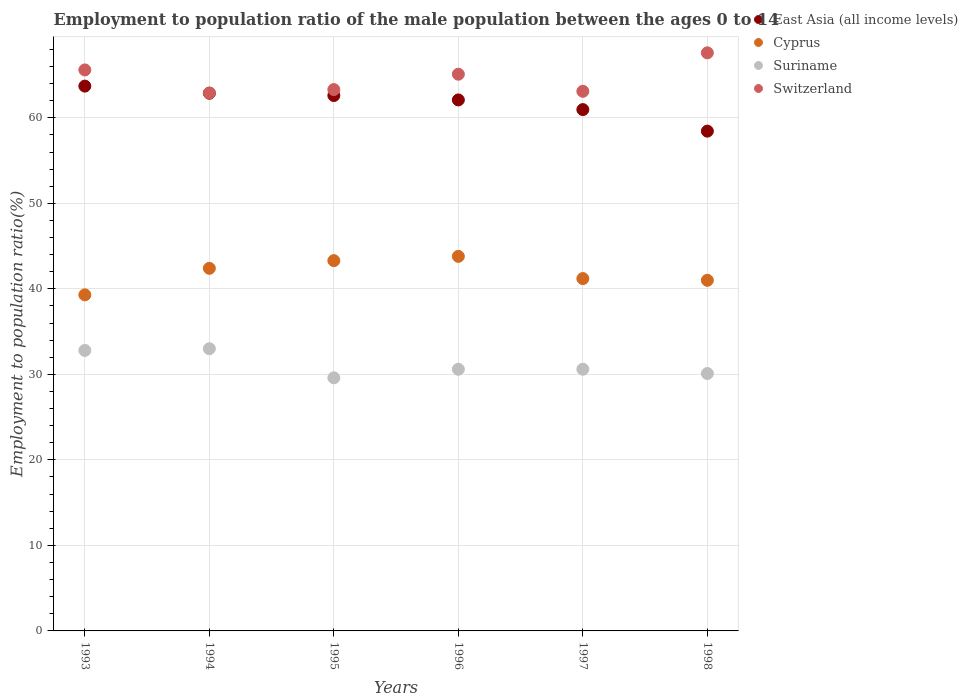How many different coloured dotlines are there?
Keep it short and to the point. 4. What is the employment to population ratio in Switzerland in 1996?
Provide a short and direct response. 65.1. Across all years, what is the maximum employment to population ratio in Suriname?
Make the answer very short. 33. Across all years, what is the minimum employment to population ratio in Suriname?
Make the answer very short. 29.6. In which year was the employment to population ratio in Suriname maximum?
Make the answer very short. 1994. In which year was the employment to population ratio in Suriname minimum?
Offer a very short reply. 1995. What is the total employment to population ratio in East Asia (all income levels) in the graph?
Offer a very short reply. 370.69. What is the difference between the employment to population ratio in Suriname in 1993 and that in 1994?
Ensure brevity in your answer.  -0.2. What is the difference between the employment to population ratio in Suriname in 1998 and the employment to population ratio in East Asia (all income levels) in 1994?
Provide a short and direct response. -32.77. What is the average employment to population ratio in Cyprus per year?
Your response must be concise. 41.83. In the year 1995, what is the difference between the employment to population ratio in Switzerland and employment to population ratio in Suriname?
Your answer should be very brief. 33.7. What is the ratio of the employment to population ratio in Cyprus in 1995 to that in 1998?
Make the answer very short. 1.06. What is the difference between the highest and the second highest employment to population ratio in Cyprus?
Provide a short and direct response. 0.5. What is the difference between the highest and the lowest employment to population ratio in Cyprus?
Offer a very short reply. 4.5. Is the sum of the employment to population ratio in Suriname in 1993 and 1996 greater than the maximum employment to population ratio in East Asia (all income levels) across all years?
Keep it short and to the point. No. Is it the case that in every year, the sum of the employment to population ratio in East Asia (all income levels) and employment to population ratio in Cyprus  is greater than the sum of employment to population ratio in Switzerland and employment to population ratio in Suriname?
Provide a succinct answer. Yes. Does the employment to population ratio in Switzerland monotonically increase over the years?
Offer a terse response. No. How many dotlines are there?
Your answer should be compact. 4. Where does the legend appear in the graph?
Offer a terse response. Top right. How are the legend labels stacked?
Offer a very short reply. Vertical. What is the title of the graph?
Offer a very short reply. Employment to population ratio of the male population between the ages 0 to 14. What is the label or title of the X-axis?
Your answer should be compact. Years. What is the label or title of the Y-axis?
Give a very brief answer. Employment to population ratio(%). What is the Employment to population ratio(%) of East Asia (all income levels) in 1993?
Ensure brevity in your answer.  63.71. What is the Employment to population ratio(%) of Cyprus in 1993?
Offer a very short reply. 39.3. What is the Employment to population ratio(%) of Suriname in 1993?
Offer a very short reply. 32.8. What is the Employment to population ratio(%) of Switzerland in 1993?
Your response must be concise. 65.6. What is the Employment to population ratio(%) of East Asia (all income levels) in 1994?
Offer a very short reply. 62.87. What is the Employment to population ratio(%) in Cyprus in 1994?
Your answer should be very brief. 42.4. What is the Employment to population ratio(%) in Switzerland in 1994?
Offer a terse response. 62.9. What is the Employment to population ratio(%) of East Asia (all income levels) in 1995?
Make the answer very short. 62.61. What is the Employment to population ratio(%) of Cyprus in 1995?
Offer a terse response. 43.3. What is the Employment to population ratio(%) in Suriname in 1995?
Make the answer very short. 29.6. What is the Employment to population ratio(%) of Switzerland in 1995?
Provide a short and direct response. 63.3. What is the Employment to population ratio(%) of East Asia (all income levels) in 1996?
Provide a short and direct response. 62.09. What is the Employment to population ratio(%) in Cyprus in 1996?
Make the answer very short. 43.8. What is the Employment to population ratio(%) in Suriname in 1996?
Provide a short and direct response. 30.6. What is the Employment to population ratio(%) of Switzerland in 1996?
Offer a terse response. 65.1. What is the Employment to population ratio(%) in East Asia (all income levels) in 1997?
Keep it short and to the point. 60.96. What is the Employment to population ratio(%) in Cyprus in 1997?
Offer a very short reply. 41.2. What is the Employment to population ratio(%) in Suriname in 1997?
Offer a very short reply. 30.6. What is the Employment to population ratio(%) in Switzerland in 1997?
Your answer should be compact. 63.1. What is the Employment to population ratio(%) of East Asia (all income levels) in 1998?
Your answer should be very brief. 58.44. What is the Employment to population ratio(%) of Suriname in 1998?
Offer a very short reply. 30.1. What is the Employment to population ratio(%) of Switzerland in 1998?
Your answer should be compact. 67.6. Across all years, what is the maximum Employment to population ratio(%) in East Asia (all income levels)?
Provide a succinct answer. 63.71. Across all years, what is the maximum Employment to population ratio(%) in Cyprus?
Your response must be concise. 43.8. Across all years, what is the maximum Employment to population ratio(%) in Suriname?
Make the answer very short. 33. Across all years, what is the maximum Employment to population ratio(%) of Switzerland?
Provide a short and direct response. 67.6. Across all years, what is the minimum Employment to population ratio(%) of East Asia (all income levels)?
Keep it short and to the point. 58.44. Across all years, what is the minimum Employment to population ratio(%) in Cyprus?
Your answer should be very brief. 39.3. Across all years, what is the minimum Employment to population ratio(%) in Suriname?
Offer a terse response. 29.6. Across all years, what is the minimum Employment to population ratio(%) in Switzerland?
Make the answer very short. 62.9. What is the total Employment to population ratio(%) in East Asia (all income levels) in the graph?
Keep it short and to the point. 370.69. What is the total Employment to population ratio(%) in Cyprus in the graph?
Keep it short and to the point. 251. What is the total Employment to population ratio(%) of Suriname in the graph?
Your answer should be very brief. 186.7. What is the total Employment to population ratio(%) of Switzerland in the graph?
Keep it short and to the point. 387.6. What is the difference between the Employment to population ratio(%) in East Asia (all income levels) in 1993 and that in 1994?
Provide a succinct answer. 0.83. What is the difference between the Employment to population ratio(%) of Cyprus in 1993 and that in 1994?
Make the answer very short. -3.1. What is the difference between the Employment to population ratio(%) in East Asia (all income levels) in 1993 and that in 1995?
Keep it short and to the point. 1.1. What is the difference between the Employment to population ratio(%) of Cyprus in 1993 and that in 1995?
Your response must be concise. -4. What is the difference between the Employment to population ratio(%) of Switzerland in 1993 and that in 1995?
Provide a succinct answer. 2.3. What is the difference between the Employment to population ratio(%) of East Asia (all income levels) in 1993 and that in 1996?
Your answer should be very brief. 1.62. What is the difference between the Employment to population ratio(%) in Cyprus in 1993 and that in 1996?
Offer a very short reply. -4.5. What is the difference between the Employment to population ratio(%) of Switzerland in 1993 and that in 1996?
Your answer should be very brief. 0.5. What is the difference between the Employment to population ratio(%) of East Asia (all income levels) in 1993 and that in 1997?
Make the answer very short. 2.75. What is the difference between the Employment to population ratio(%) in East Asia (all income levels) in 1993 and that in 1998?
Give a very brief answer. 5.26. What is the difference between the Employment to population ratio(%) in Suriname in 1993 and that in 1998?
Offer a very short reply. 2.7. What is the difference between the Employment to population ratio(%) of Switzerland in 1993 and that in 1998?
Keep it short and to the point. -2. What is the difference between the Employment to population ratio(%) of East Asia (all income levels) in 1994 and that in 1995?
Offer a terse response. 0.27. What is the difference between the Employment to population ratio(%) in Cyprus in 1994 and that in 1995?
Keep it short and to the point. -0.9. What is the difference between the Employment to population ratio(%) in Suriname in 1994 and that in 1995?
Your response must be concise. 3.4. What is the difference between the Employment to population ratio(%) in Switzerland in 1994 and that in 1995?
Your response must be concise. -0.4. What is the difference between the Employment to population ratio(%) in East Asia (all income levels) in 1994 and that in 1996?
Ensure brevity in your answer.  0.78. What is the difference between the Employment to population ratio(%) in East Asia (all income levels) in 1994 and that in 1997?
Provide a succinct answer. 1.91. What is the difference between the Employment to population ratio(%) in Cyprus in 1994 and that in 1997?
Ensure brevity in your answer.  1.2. What is the difference between the Employment to population ratio(%) in Suriname in 1994 and that in 1997?
Offer a terse response. 2.4. What is the difference between the Employment to population ratio(%) in East Asia (all income levels) in 1994 and that in 1998?
Ensure brevity in your answer.  4.43. What is the difference between the Employment to population ratio(%) in Cyprus in 1994 and that in 1998?
Your response must be concise. 1.4. What is the difference between the Employment to population ratio(%) of Suriname in 1994 and that in 1998?
Your answer should be very brief. 2.9. What is the difference between the Employment to population ratio(%) of East Asia (all income levels) in 1995 and that in 1996?
Make the answer very short. 0.52. What is the difference between the Employment to population ratio(%) in Suriname in 1995 and that in 1996?
Offer a very short reply. -1. What is the difference between the Employment to population ratio(%) in East Asia (all income levels) in 1995 and that in 1997?
Make the answer very short. 1.65. What is the difference between the Employment to population ratio(%) of East Asia (all income levels) in 1995 and that in 1998?
Ensure brevity in your answer.  4.17. What is the difference between the Employment to population ratio(%) of Cyprus in 1995 and that in 1998?
Your answer should be compact. 2.3. What is the difference between the Employment to population ratio(%) in Suriname in 1995 and that in 1998?
Give a very brief answer. -0.5. What is the difference between the Employment to population ratio(%) in East Asia (all income levels) in 1996 and that in 1997?
Keep it short and to the point. 1.13. What is the difference between the Employment to population ratio(%) of Suriname in 1996 and that in 1997?
Provide a short and direct response. 0. What is the difference between the Employment to population ratio(%) in Switzerland in 1996 and that in 1997?
Offer a very short reply. 2. What is the difference between the Employment to population ratio(%) of East Asia (all income levels) in 1996 and that in 1998?
Offer a very short reply. 3.65. What is the difference between the Employment to population ratio(%) of Cyprus in 1996 and that in 1998?
Provide a succinct answer. 2.8. What is the difference between the Employment to population ratio(%) in East Asia (all income levels) in 1997 and that in 1998?
Provide a succinct answer. 2.52. What is the difference between the Employment to population ratio(%) in Suriname in 1997 and that in 1998?
Keep it short and to the point. 0.5. What is the difference between the Employment to population ratio(%) of East Asia (all income levels) in 1993 and the Employment to population ratio(%) of Cyprus in 1994?
Your response must be concise. 21.31. What is the difference between the Employment to population ratio(%) in East Asia (all income levels) in 1993 and the Employment to population ratio(%) in Suriname in 1994?
Provide a succinct answer. 30.71. What is the difference between the Employment to population ratio(%) of East Asia (all income levels) in 1993 and the Employment to population ratio(%) of Switzerland in 1994?
Make the answer very short. 0.81. What is the difference between the Employment to population ratio(%) of Cyprus in 1993 and the Employment to population ratio(%) of Suriname in 1994?
Make the answer very short. 6.3. What is the difference between the Employment to population ratio(%) in Cyprus in 1993 and the Employment to population ratio(%) in Switzerland in 1994?
Ensure brevity in your answer.  -23.6. What is the difference between the Employment to population ratio(%) of Suriname in 1993 and the Employment to population ratio(%) of Switzerland in 1994?
Keep it short and to the point. -30.1. What is the difference between the Employment to population ratio(%) in East Asia (all income levels) in 1993 and the Employment to population ratio(%) in Cyprus in 1995?
Keep it short and to the point. 20.41. What is the difference between the Employment to population ratio(%) of East Asia (all income levels) in 1993 and the Employment to population ratio(%) of Suriname in 1995?
Offer a very short reply. 34.11. What is the difference between the Employment to population ratio(%) in East Asia (all income levels) in 1993 and the Employment to population ratio(%) in Switzerland in 1995?
Provide a short and direct response. 0.41. What is the difference between the Employment to population ratio(%) of Suriname in 1993 and the Employment to population ratio(%) of Switzerland in 1995?
Offer a very short reply. -30.5. What is the difference between the Employment to population ratio(%) of East Asia (all income levels) in 1993 and the Employment to population ratio(%) of Cyprus in 1996?
Provide a short and direct response. 19.91. What is the difference between the Employment to population ratio(%) of East Asia (all income levels) in 1993 and the Employment to population ratio(%) of Suriname in 1996?
Provide a succinct answer. 33.11. What is the difference between the Employment to population ratio(%) of East Asia (all income levels) in 1993 and the Employment to population ratio(%) of Switzerland in 1996?
Offer a terse response. -1.39. What is the difference between the Employment to population ratio(%) in Cyprus in 1993 and the Employment to population ratio(%) in Switzerland in 1996?
Provide a succinct answer. -25.8. What is the difference between the Employment to population ratio(%) of Suriname in 1993 and the Employment to population ratio(%) of Switzerland in 1996?
Provide a short and direct response. -32.3. What is the difference between the Employment to population ratio(%) in East Asia (all income levels) in 1993 and the Employment to population ratio(%) in Cyprus in 1997?
Offer a terse response. 22.51. What is the difference between the Employment to population ratio(%) of East Asia (all income levels) in 1993 and the Employment to population ratio(%) of Suriname in 1997?
Provide a short and direct response. 33.11. What is the difference between the Employment to population ratio(%) in East Asia (all income levels) in 1993 and the Employment to population ratio(%) in Switzerland in 1997?
Give a very brief answer. 0.61. What is the difference between the Employment to population ratio(%) in Cyprus in 1993 and the Employment to population ratio(%) in Suriname in 1997?
Your response must be concise. 8.7. What is the difference between the Employment to population ratio(%) in Cyprus in 1993 and the Employment to population ratio(%) in Switzerland in 1997?
Your response must be concise. -23.8. What is the difference between the Employment to population ratio(%) in Suriname in 1993 and the Employment to population ratio(%) in Switzerland in 1997?
Keep it short and to the point. -30.3. What is the difference between the Employment to population ratio(%) of East Asia (all income levels) in 1993 and the Employment to population ratio(%) of Cyprus in 1998?
Offer a very short reply. 22.71. What is the difference between the Employment to population ratio(%) of East Asia (all income levels) in 1993 and the Employment to population ratio(%) of Suriname in 1998?
Your answer should be very brief. 33.61. What is the difference between the Employment to population ratio(%) of East Asia (all income levels) in 1993 and the Employment to population ratio(%) of Switzerland in 1998?
Offer a very short reply. -3.89. What is the difference between the Employment to population ratio(%) of Cyprus in 1993 and the Employment to population ratio(%) of Suriname in 1998?
Offer a very short reply. 9.2. What is the difference between the Employment to population ratio(%) in Cyprus in 1993 and the Employment to population ratio(%) in Switzerland in 1998?
Provide a short and direct response. -28.3. What is the difference between the Employment to population ratio(%) of Suriname in 1993 and the Employment to population ratio(%) of Switzerland in 1998?
Your answer should be compact. -34.8. What is the difference between the Employment to population ratio(%) in East Asia (all income levels) in 1994 and the Employment to population ratio(%) in Cyprus in 1995?
Your answer should be compact. 19.57. What is the difference between the Employment to population ratio(%) of East Asia (all income levels) in 1994 and the Employment to population ratio(%) of Suriname in 1995?
Your answer should be compact. 33.27. What is the difference between the Employment to population ratio(%) of East Asia (all income levels) in 1994 and the Employment to population ratio(%) of Switzerland in 1995?
Ensure brevity in your answer.  -0.43. What is the difference between the Employment to population ratio(%) of Cyprus in 1994 and the Employment to population ratio(%) of Suriname in 1995?
Offer a terse response. 12.8. What is the difference between the Employment to population ratio(%) in Cyprus in 1994 and the Employment to population ratio(%) in Switzerland in 1995?
Ensure brevity in your answer.  -20.9. What is the difference between the Employment to population ratio(%) of Suriname in 1994 and the Employment to population ratio(%) of Switzerland in 1995?
Your response must be concise. -30.3. What is the difference between the Employment to population ratio(%) in East Asia (all income levels) in 1994 and the Employment to population ratio(%) in Cyprus in 1996?
Keep it short and to the point. 19.07. What is the difference between the Employment to population ratio(%) of East Asia (all income levels) in 1994 and the Employment to population ratio(%) of Suriname in 1996?
Your response must be concise. 32.27. What is the difference between the Employment to population ratio(%) in East Asia (all income levels) in 1994 and the Employment to population ratio(%) in Switzerland in 1996?
Offer a very short reply. -2.23. What is the difference between the Employment to population ratio(%) of Cyprus in 1994 and the Employment to population ratio(%) of Switzerland in 1996?
Your answer should be very brief. -22.7. What is the difference between the Employment to population ratio(%) of Suriname in 1994 and the Employment to population ratio(%) of Switzerland in 1996?
Make the answer very short. -32.1. What is the difference between the Employment to population ratio(%) of East Asia (all income levels) in 1994 and the Employment to population ratio(%) of Cyprus in 1997?
Your answer should be very brief. 21.67. What is the difference between the Employment to population ratio(%) in East Asia (all income levels) in 1994 and the Employment to population ratio(%) in Suriname in 1997?
Offer a very short reply. 32.27. What is the difference between the Employment to population ratio(%) of East Asia (all income levels) in 1994 and the Employment to population ratio(%) of Switzerland in 1997?
Provide a short and direct response. -0.23. What is the difference between the Employment to population ratio(%) of Cyprus in 1994 and the Employment to population ratio(%) of Suriname in 1997?
Your answer should be compact. 11.8. What is the difference between the Employment to population ratio(%) of Cyprus in 1994 and the Employment to population ratio(%) of Switzerland in 1997?
Give a very brief answer. -20.7. What is the difference between the Employment to population ratio(%) in Suriname in 1994 and the Employment to population ratio(%) in Switzerland in 1997?
Your response must be concise. -30.1. What is the difference between the Employment to population ratio(%) in East Asia (all income levels) in 1994 and the Employment to population ratio(%) in Cyprus in 1998?
Give a very brief answer. 21.87. What is the difference between the Employment to population ratio(%) in East Asia (all income levels) in 1994 and the Employment to population ratio(%) in Suriname in 1998?
Your response must be concise. 32.77. What is the difference between the Employment to population ratio(%) in East Asia (all income levels) in 1994 and the Employment to population ratio(%) in Switzerland in 1998?
Your response must be concise. -4.73. What is the difference between the Employment to population ratio(%) of Cyprus in 1994 and the Employment to population ratio(%) of Suriname in 1998?
Give a very brief answer. 12.3. What is the difference between the Employment to population ratio(%) in Cyprus in 1994 and the Employment to population ratio(%) in Switzerland in 1998?
Ensure brevity in your answer.  -25.2. What is the difference between the Employment to population ratio(%) in Suriname in 1994 and the Employment to population ratio(%) in Switzerland in 1998?
Provide a short and direct response. -34.6. What is the difference between the Employment to population ratio(%) in East Asia (all income levels) in 1995 and the Employment to population ratio(%) in Cyprus in 1996?
Ensure brevity in your answer.  18.81. What is the difference between the Employment to population ratio(%) in East Asia (all income levels) in 1995 and the Employment to population ratio(%) in Suriname in 1996?
Ensure brevity in your answer.  32.01. What is the difference between the Employment to population ratio(%) of East Asia (all income levels) in 1995 and the Employment to population ratio(%) of Switzerland in 1996?
Your answer should be very brief. -2.49. What is the difference between the Employment to population ratio(%) in Cyprus in 1995 and the Employment to population ratio(%) in Suriname in 1996?
Provide a short and direct response. 12.7. What is the difference between the Employment to population ratio(%) in Cyprus in 1995 and the Employment to population ratio(%) in Switzerland in 1996?
Your answer should be compact. -21.8. What is the difference between the Employment to population ratio(%) in Suriname in 1995 and the Employment to population ratio(%) in Switzerland in 1996?
Ensure brevity in your answer.  -35.5. What is the difference between the Employment to population ratio(%) in East Asia (all income levels) in 1995 and the Employment to population ratio(%) in Cyprus in 1997?
Your answer should be compact. 21.41. What is the difference between the Employment to population ratio(%) of East Asia (all income levels) in 1995 and the Employment to population ratio(%) of Suriname in 1997?
Make the answer very short. 32.01. What is the difference between the Employment to population ratio(%) of East Asia (all income levels) in 1995 and the Employment to population ratio(%) of Switzerland in 1997?
Give a very brief answer. -0.49. What is the difference between the Employment to population ratio(%) in Cyprus in 1995 and the Employment to population ratio(%) in Switzerland in 1997?
Keep it short and to the point. -19.8. What is the difference between the Employment to population ratio(%) of Suriname in 1995 and the Employment to population ratio(%) of Switzerland in 1997?
Your response must be concise. -33.5. What is the difference between the Employment to population ratio(%) of East Asia (all income levels) in 1995 and the Employment to population ratio(%) of Cyprus in 1998?
Keep it short and to the point. 21.61. What is the difference between the Employment to population ratio(%) of East Asia (all income levels) in 1995 and the Employment to population ratio(%) of Suriname in 1998?
Your response must be concise. 32.51. What is the difference between the Employment to population ratio(%) of East Asia (all income levels) in 1995 and the Employment to population ratio(%) of Switzerland in 1998?
Offer a terse response. -4.99. What is the difference between the Employment to population ratio(%) of Cyprus in 1995 and the Employment to population ratio(%) of Suriname in 1998?
Your answer should be very brief. 13.2. What is the difference between the Employment to population ratio(%) of Cyprus in 1995 and the Employment to population ratio(%) of Switzerland in 1998?
Your answer should be compact. -24.3. What is the difference between the Employment to population ratio(%) of Suriname in 1995 and the Employment to population ratio(%) of Switzerland in 1998?
Ensure brevity in your answer.  -38. What is the difference between the Employment to population ratio(%) of East Asia (all income levels) in 1996 and the Employment to population ratio(%) of Cyprus in 1997?
Offer a very short reply. 20.89. What is the difference between the Employment to population ratio(%) in East Asia (all income levels) in 1996 and the Employment to population ratio(%) in Suriname in 1997?
Ensure brevity in your answer.  31.49. What is the difference between the Employment to population ratio(%) in East Asia (all income levels) in 1996 and the Employment to population ratio(%) in Switzerland in 1997?
Keep it short and to the point. -1.01. What is the difference between the Employment to population ratio(%) of Cyprus in 1996 and the Employment to population ratio(%) of Suriname in 1997?
Keep it short and to the point. 13.2. What is the difference between the Employment to population ratio(%) of Cyprus in 1996 and the Employment to population ratio(%) of Switzerland in 1997?
Your answer should be very brief. -19.3. What is the difference between the Employment to population ratio(%) of Suriname in 1996 and the Employment to population ratio(%) of Switzerland in 1997?
Provide a short and direct response. -32.5. What is the difference between the Employment to population ratio(%) of East Asia (all income levels) in 1996 and the Employment to population ratio(%) of Cyprus in 1998?
Offer a very short reply. 21.09. What is the difference between the Employment to population ratio(%) of East Asia (all income levels) in 1996 and the Employment to population ratio(%) of Suriname in 1998?
Keep it short and to the point. 31.99. What is the difference between the Employment to population ratio(%) in East Asia (all income levels) in 1996 and the Employment to population ratio(%) in Switzerland in 1998?
Offer a very short reply. -5.51. What is the difference between the Employment to population ratio(%) of Cyprus in 1996 and the Employment to population ratio(%) of Suriname in 1998?
Your answer should be very brief. 13.7. What is the difference between the Employment to population ratio(%) in Cyprus in 1996 and the Employment to population ratio(%) in Switzerland in 1998?
Your answer should be very brief. -23.8. What is the difference between the Employment to population ratio(%) of Suriname in 1996 and the Employment to population ratio(%) of Switzerland in 1998?
Your answer should be very brief. -37. What is the difference between the Employment to population ratio(%) of East Asia (all income levels) in 1997 and the Employment to population ratio(%) of Cyprus in 1998?
Provide a succinct answer. 19.96. What is the difference between the Employment to population ratio(%) in East Asia (all income levels) in 1997 and the Employment to population ratio(%) in Suriname in 1998?
Offer a terse response. 30.86. What is the difference between the Employment to population ratio(%) in East Asia (all income levels) in 1997 and the Employment to population ratio(%) in Switzerland in 1998?
Your answer should be compact. -6.64. What is the difference between the Employment to population ratio(%) in Cyprus in 1997 and the Employment to population ratio(%) in Suriname in 1998?
Provide a succinct answer. 11.1. What is the difference between the Employment to population ratio(%) of Cyprus in 1997 and the Employment to population ratio(%) of Switzerland in 1998?
Provide a succinct answer. -26.4. What is the difference between the Employment to population ratio(%) in Suriname in 1997 and the Employment to population ratio(%) in Switzerland in 1998?
Make the answer very short. -37. What is the average Employment to population ratio(%) in East Asia (all income levels) per year?
Offer a terse response. 61.78. What is the average Employment to population ratio(%) of Cyprus per year?
Your answer should be very brief. 41.83. What is the average Employment to population ratio(%) of Suriname per year?
Provide a succinct answer. 31.12. What is the average Employment to population ratio(%) in Switzerland per year?
Provide a succinct answer. 64.6. In the year 1993, what is the difference between the Employment to population ratio(%) of East Asia (all income levels) and Employment to population ratio(%) of Cyprus?
Offer a very short reply. 24.41. In the year 1993, what is the difference between the Employment to population ratio(%) in East Asia (all income levels) and Employment to population ratio(%) in Suriname?
Make the answer very short. 30.91. In the year 1993, what is the difference between the Employment to population ratio(%) of East Asia (all income levels) and Employment to population ratio(%) of Switzerland?
Your answer should be compact. -1.89. In the year 1993, what is the difference between the Employment to population ratio(%) in Cyprus and Employment to population ratio(%) in Suriname?
Offer a terse response. 6.5. In the year 1993, what is the difference between the Employment to population ratio(%) in Cyprus and Employment to population ratio(%) in Switzerland?
Give a very brief answer. -26.3. In the year 1993, what is the difference between the Employment to population ratio(%) in Suriname and Employment to population ratio(%) in Switzerland?
Make the answer very short. -32.8. In the year 1994, what is the difference between the Employment to population ratio(%) of East Asia (all income levels) and Employment to population ratio(%) of Cyprus?
Ensure brevity in your answer.  20.47. In the year 1994, what is the difference between the Employment to population ratio(%) in East Asia (all income levels) and Employment to population ratio(%) in Suriname?
Make the answer very short. 29.87. In the year 1994, what is the difference between the Employment to population ratio(%) in East Asia (all income levels) and Employment to population ratio(%) in Switzerland?
Offer a very short reply. -0.03. In the year 1994, what is the difference between the Employment to population ratio(%) in Cyprus and Employment to population ratio(%) in Suriname?
Your answer should be compact. 9.4. In the year 1994, what is the difference between the Employment to population ratio(%) in Cyprus and Employment to population ratio(%) in Switzerland?
Make the answer very short. -20.5. In the year 1994, what is the difference between the Employment to population ratio(%) in Suriname and Employment to population ratio(%) in Switzerland?
Your answer should be very brief. -29.9. In the year 1995, what is the difference between the Employment to population ratio(%) in East Asia (all income levels) and Employment to population ratio(%) in Cyprus?
Offer a very short reply. 19.31. In the year 1995, what is the difference between the Employment to population ratio(%) of East Asia (all income levels) and Employment to population ratio(%) of Suriname?
Your answer should be very brief. 33.01. In the year 1995, what is the difference between the Employment to population ratio(%) in East Asia (all income levels) and Employment to population ratio(%) in Switzerland?
Give a very brief answer. -0.69. In the year 1995, what is the difference between the Employment to population ratio(%) of Cyprus and Employment to population ratio(%) of Suriname?
Keep it short and to the point. 13.7. In the year 1995, what is the difference between the Employment to population ratio(%) of Suriname and Employment to population ratio(%) of Switzerland?
Provide a succinct answer. -33.7. In the year 1996, what is the difference between the Employment to population ratio(%) in East Asia (all income levels) and Employment to population ratio(%) in Cyprus?
Provide a succinct answer. 18.29. In the year 1996, what is the difference between the Employment to population ratio(%) of East Asia (all income levels) and Employment to population ratio(%) of Suriname?
Ensure brevity in your answer.  31.49. In the year 1996, what is the difference between the Employment to population ratio(%) in East Asia (all income levels) and Employment to population ratio(%) in Switzerland?
Keep it short and to the point. -3.01. In the year 1996, what is the difference between the Employment to population ratio(%) in Cyprus and Employment to population ratio(%) in Suriname?
Provide a short and direct response. 13.2. In the year 1996, what is the difference between the Employment to population ratio(%) in Cyprus and Employment to population ratio(%) in Switzerland?
Keep it short and to the point. -21.3. In the year 1996, what is the difference between the Employment to population ratio(%) of Suriname and Employment to population ratio(%) of Switzerland?
Make the answer very short. -34.5. In the year 1997, what is the difference between the Employment to population ratio(%) in East Asia (all income levels) and Employment to population ratio(%) in Cyprus?
Your answer should be compact. 19.76. In the year 1997, what is the difference between the Employment to population ratio(%) in East Asia (all income levels) and Employment to population ratio(%) in Suriname?
Ensure brevity in your answer.  30.36. In the year 1997, what is the difference between the Employment to population ratio(%) of East Asia (all income levels) and Employment to population ratio(%) of Switzerland?
Offer a very short reply. -2.14. In the year 1997, what is the difference between the Employment to population ratio(%) of Cyprus and Employment to population ratio(%) of Suriname?
Offer a very short reply. 10.6. In the year 1997, what is the difference between the Employment to population ratio(%) of Cyprus and Employment to population ratio(%) of Switzerland?
Provide a succinct answer. -21.9. In the year 1997, what is the difference between the Employment to population ratio(%) of Suriname and Employment to population ratio(%) of Switzerland?
Ensure brevity in your answer.  -32.5. In the year 1998, what is the difference between the Employment to population ratio(%) of East Asia (all income levels) and Employment to population ratio(%) of Cyprus?
Provide a succinct answer. 17.44. In the year 1998, what is the difference between the Employment to population ratio(%) in East Asia (all income levels) and Employment to population ratio(%) in Suriname?
Keep it short and to the point. 28.34. In the year 1998, what is the difference between the Employment to population ratio(%) of East Asia (all income levels) and Employment to population ratio(%) of Switzerland?
Your answer should be compact. -9.16. In the year 1998, what is the difference between the Employment to population ratio(%) in Cyprus and Employment to population ratio(%) in Switzerland?
Keep it short and to the point. -26.6. In the year 1998, what is the difference between the Employment to population ratio(%) of Suriname and Employment to population ratio(%) of Switzerland?
Your answer should be very brief. -37.5. What is the ratio of the Employment to population ratio(%) of East Asia (all income levels) in 1993 to that in 1994?
Keep it short and to the point. 1.01. What is the ratio of the Employment to population ratio(%) of Cyprus in 1993 to that in 1994?
Keep it short and to the point. 0.93. What is the ratio of the Employment to population ratio(%) in Switzerland in 1993 to that in 1994?
Keep it short and to the point. 1.04. What is the ratio of the Employment to population ratio(%) in East Asia (all income levels) in 1993 to that in 1995?
Your answer should be very brief. 1.02. What is the ratio of the Employment to population ratio(%) in Cyprus in 1993 to that in 1995?
Keep it short and to the point. 0.91. What is the ratio of the Employment to population ratio(%) of Suriname in 1993 to that in 1995?
Your response must be concise. 1.11. What is the ratio of the Employment to population ratio(%) in Switzerland in 1993 to that in 1995?
Provide a succinct answer. 1.04. What is the ratio of the Employment to population ratio(%) in East Asia (all income levels) in 1993 to that in 1996?
Your answer should be very brief. 1.03. What is the ratio of the Employment to population ratio(%) in Cyprus in 1993 to that in 1996?
Your answer should be very brief. 0.9. What is the ratio of the Employment to population ratio(%) in Suriname in 1993 to that in 1996?
Give a very brief answer. 1.07. What is the ratio of the Employment to population ratio(%) in Switzerland in 1993 to that in 1996?
Your answer should be compact. 1.01. What is the ratio of the Employment to population ratio(%) of East Asia (all income levels) in 1993 to that in 1997?
Provide a succinct answer. 1.04. What is the ratio of the Employment to population ratio(%) in Cyprus in 1993 to that in 1997?
Keep it short and to the point. 0.95. What is the ratio of the Employment to population ratio(%) of Suriname in 1993 to that in 1997?
Give a very brief answer. 1.07. What is the ratio of the Employment to population ratio(%) in Switzerland in 1993 to that in 1997?
Offer a very short reply. 1.04. What is the ratio of the Employment to population ratio(%) in East Asia (all income levels) in 1993 to that in 1998?
Give a very brief answer. 1.09. What is the ratio of the Employment to population ratio(%) in Cyprus in 1993 to that in 1998?
Offer a very short reply. 0.96. What is the ratio of the Employment to population ratio(%) in Suriname in 1993 to that in 1998?
Offer a very short reply. 1.09. What is the ratio of the Employment to population ratio(%) of Switzerland in 1993 to that in 1998?
Your answer should be compact. 0.97. What is the ratio of the Employment to population ratio(%) in East Asia (all income levels) in 1994 to that in 1995?
Your response must be concise. 1. What is the ratio of the Employment to population ratio(%) in Cyprus in 1994 to that in 1995?
Keep it short and to the point. 0.98. What is the ratio of the Employment to population ratio(%) in Suriname in 1994 to that in 1995?
Offer a very short reply. 1.11. What is the ratio of the Employment to population ratio(%) of East Asia (all income levels) in 1994 to that in 1996?
Your answer should be very brief. 1.01. What is the ratio of the Employment to population ratio(%) in Suriname in 1994 to that in 1996?
Your answer should be very brief. 1.08. What is the ratio of the Employment to population ratio(%) in Switzerland in 1994 to that in 1996?
Your response must be concise. 0.97. What is the ratio of the Employment to population ratio(%) of East Asia (all income levels) in 1994 to that in 1997?
Offer a terse response. 1.03. What is the ratio of the Employment to population ratio(%) in Cyprus in 1994 to that in 1997?
Your answer should be very brief. 1.03. What is the ratio of the Employment to population ratio(%) of Suriname in 1994 to that in 1997?
Your response must be concise. 1.08. What is the ratio of the Employment to population ratio(%) in East Asia (all income levels) in 1994 to that in 1998?
Offer a very short reply. 1.08. What is the ratio of the Employment to population ratio(%) in Cyprus in 1994 to that in 1998?
Provide a succinct answer. 1.03. What is the ratio of the Employment to population ratio(%) of Suriname in 1994 to that in 1998?
Make the answer very short. 1.1. What is the ratio of the Employment to population ratio(%) in Switzerland in 1994 to that in 1998?
Give a very brief answer. 0.93. What is the ratio of the Employment to population ratio(%) in East Asia (all income levels) in 1995 to that in 1996?
Keep it short and to the point. 1.01. What is the ratio of the Employment to population ratio(%) of Suriname in 1995 to that in 1996?
Your answer should be compact. 0.97. What is the ratio of the Employment to population ratio(%) in Switzerland in 1995 to that in 1996?
Offer a terse response. 0.97. What is the ratio of the Employment to population ratio(%) of East Asia (all income levels) in 1995 to that in 1997?
Offer a very short reply. 1.03. What is the ratio of the Employment to population ratio(%) in Cyprus in 1995 to that in 1997?
Your answer should be very brief. 1.05. What is the ratio of the Employment to population ratio(%) in Suriname in 1995 to that in 1997?
Your answer should be very brief. 0.97. What is the ratio of the Employment to population ratio(%) in East Asia (all income levels) in 1995 to that in 1998?
Make the answer very short. 1.07. What is the ratio of the Employment to population ratio(%) of Cyprus in 1995 to that in 1998?
Your answer should be compact. 1.06. What is the ratio of the Employment to population ratio(%) in Suriname in 1995 to that in 1998?
Give a very brief answer. 0.98. What is the ratio of the Employment to population ratio(%) of Switzerland in 1995 to that in 1998?
Your answer should be compact. 0.94. What is the ratio of the Employment to population ratio(%) in East Asia (all income levels) in 1996 to that in 1997?
Your answer should be compact. 1.02. What is the ratio of the Employment to population ratio(%) in Cyprus in 1996 to that in 1997?
Offer a very short reply. 1.06. What is the ratio of the Employment to population ratio(%) of Switzerland in 1996 to that in 1997?
Your response must be concise. 1.03. What is the ratio of the Employment to population ratio(%) in East Asia (all income levels) in 1996 to that in 1998?
Offer a terse response. 1.06. What is the ratio of the Employment to population ratio(%) of Cyprus in 1996 to that in 1998?
Offer a very short reply. 1.07. What is the ratio of the Employment to population ratio(%) in Suriname in 1996 to that in 1998?
Your answer should be very brief. 1.02. What is the ratio of the Employment to population ratio(%) of Switzerland in 1996 to that in 1998?
Provide a short and direct response. 0.96. What is the ratio of the Employment to population ratio(%) of East Asia (all income levels) in 1997 to that in 1998?
Provide a short and direct response. 1.04. What is the ratio of the Employment to population ratio(%) of Cyprus in 1997 to that in 1998?
Provide a short and direct response. 1. What is the ratio of the Employment to population ratio(%) of Suriname in 1997 to that in 1998?
Ensure brevity in your answer.  1.02. What is the ratio of the Employment to population ratio(%) of Switzerland in 1997 to that in 1998?
Keep it short and to the point. 0.93. What is the difference between the highest and the second highest Employment to population ratio(%) in East Asia (all income levels)?
Your answer should be very brief. 0.83. What is the difference between the highest and the second highest Employment to population ratio(%) of Cyprus?
Give a very brief answer. 0.5. What is the difference between the highest and the lowest Employment to population ratio(%) in East Asia (all income levels)?
Give a very brief answer. 5.26. 